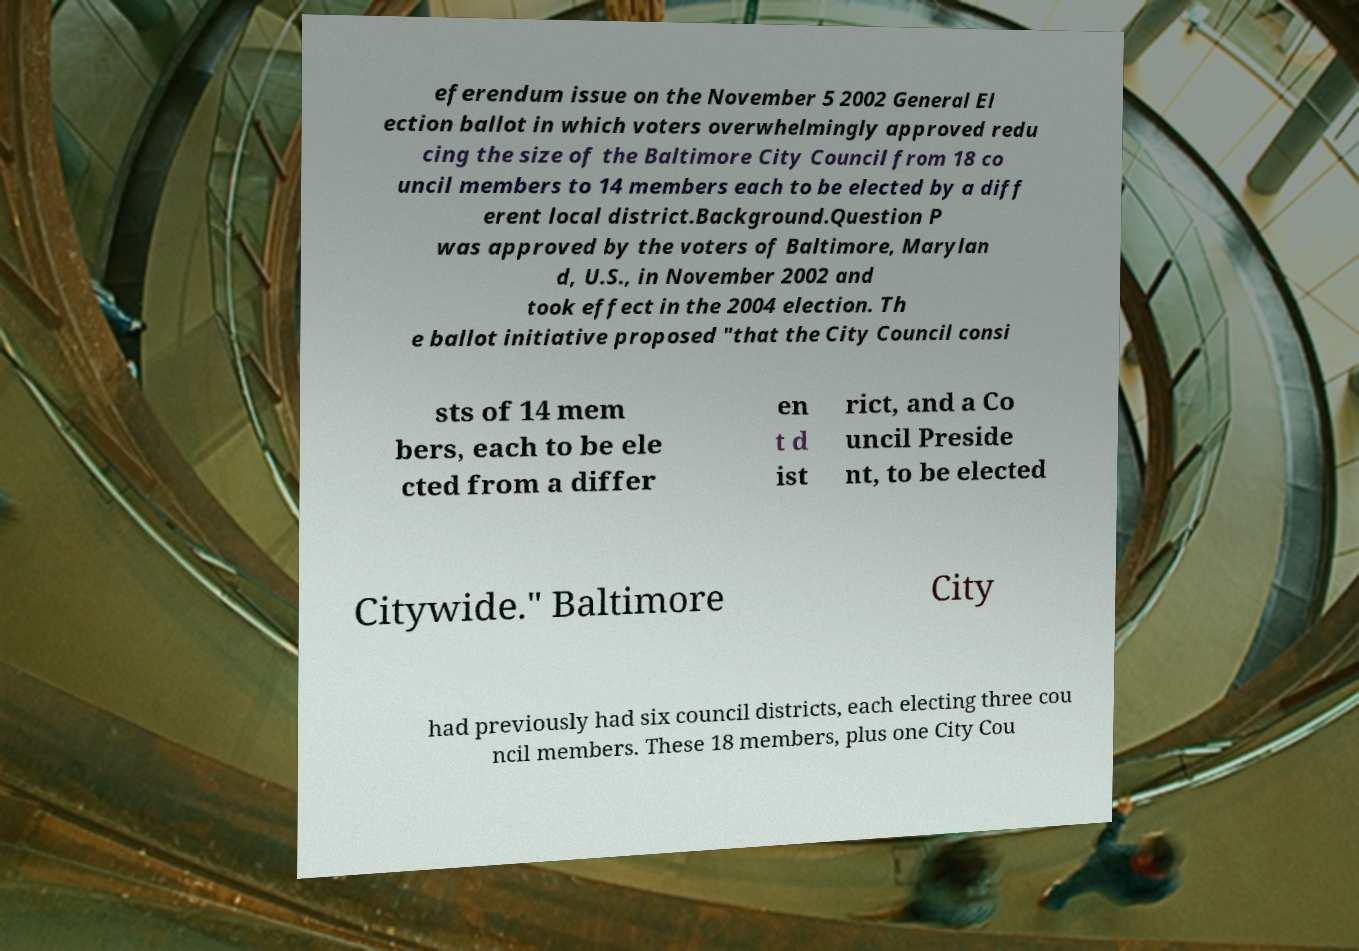Could you assist in decoding the text presented in this image and type it out clearly? eferendum issue on the November 5 2002 General El ection ballot in which voters overwhelmingly approved redu cing the size of the Baltimore City Council from 18 co uncil members to 14 members each to be elected by a diff erent local district.Background.Question P was approved by the voters of Baltimore, Marylan d, U.S., in November 2002 and took effect in the 2004 election. Th e ballot initiative proposed "that the City Council consi sts of 14 mem bers, each to be ele cted from a differ en t d ist rict, and a Co uncil Preside nt, to be elected Citywide." Baltimore City had previously had six council districts, each electing three cou ncil members. These 18 members, plus one City Cou 